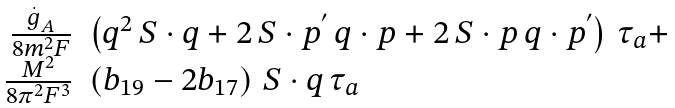Convert formula to latex. <formula><loc_0><loc_0><loc_500><loc_500>\begin{array} [ t ] { r l } \frac { \stackrel { . } { g } _ { A } } { 8 m ^ { 2 } F } & \left ( q ^ { 2 } \, S \cdot q + 2 \, S \cdot p ^ { ^ { \prime } } \, q \cdot p + 2 \, S \cdot p \, q \cdot p ^ { ^ { \prime } } \right ) \, \tau _ { a } + \\ \frac { M ^ { 2 } } { 8 \pi ^ { 2 } F ^ { 3 } } & \left ( b _ { 1 9 } - 2 b _ { 1 7 } \right ) \, S \cdot q \, \tau _ { a } \end{array}</formula> 